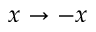Convert formula to latex. <formula><loc_0><loc_0><loc_500><loc_500>x \to - x</formula> 